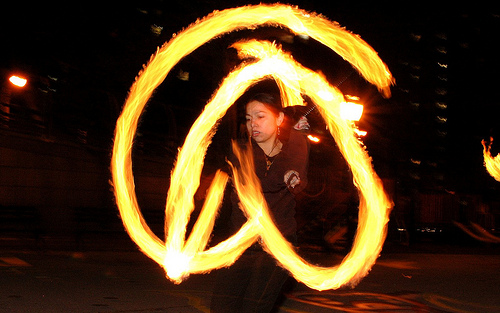<image>
Is the woman on the fire? No. The woman is not positioned on the fire. They may be near each other, but the woman is not supported by or resting on top of the fire. 